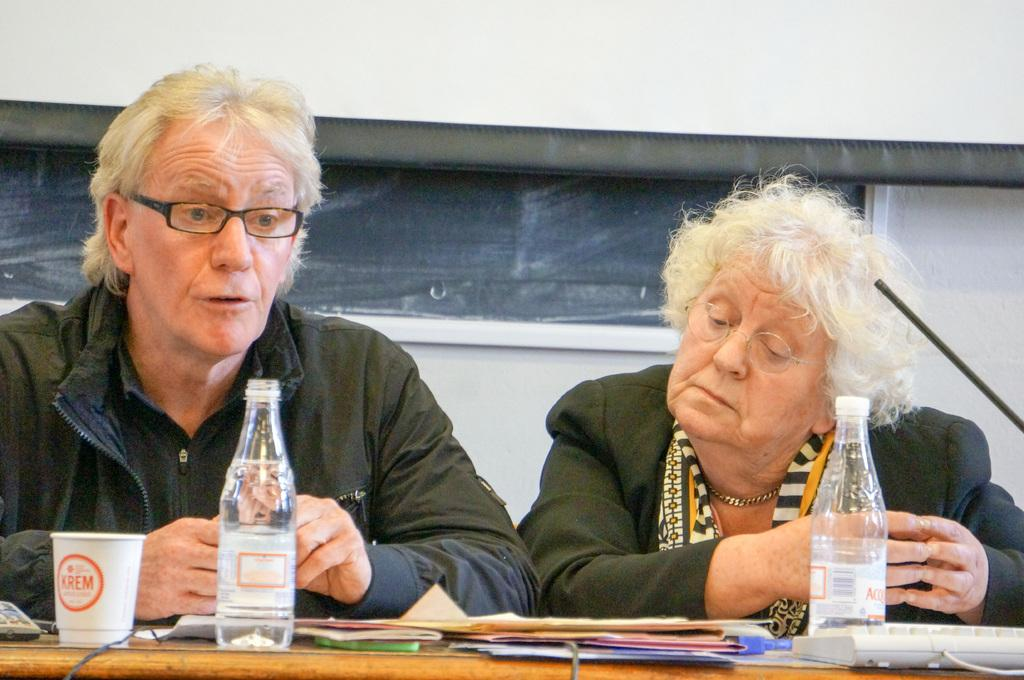Who are the people in the image? There is a man and a woman in the picture. What are they doing in the image? They are sitting in front of a table. What is the woman looking at? The woman is looking at files. What items can be seen on the table? There is a water bottle, a cup, and a keyboard on the table. What direction is the man facing in the image? The provided facts do not mention the direction the man is facing, so it cannot be determined from the image. Can you hear the woman talking in the image? The image is silent, so it is not possible to hear the woman talking. 